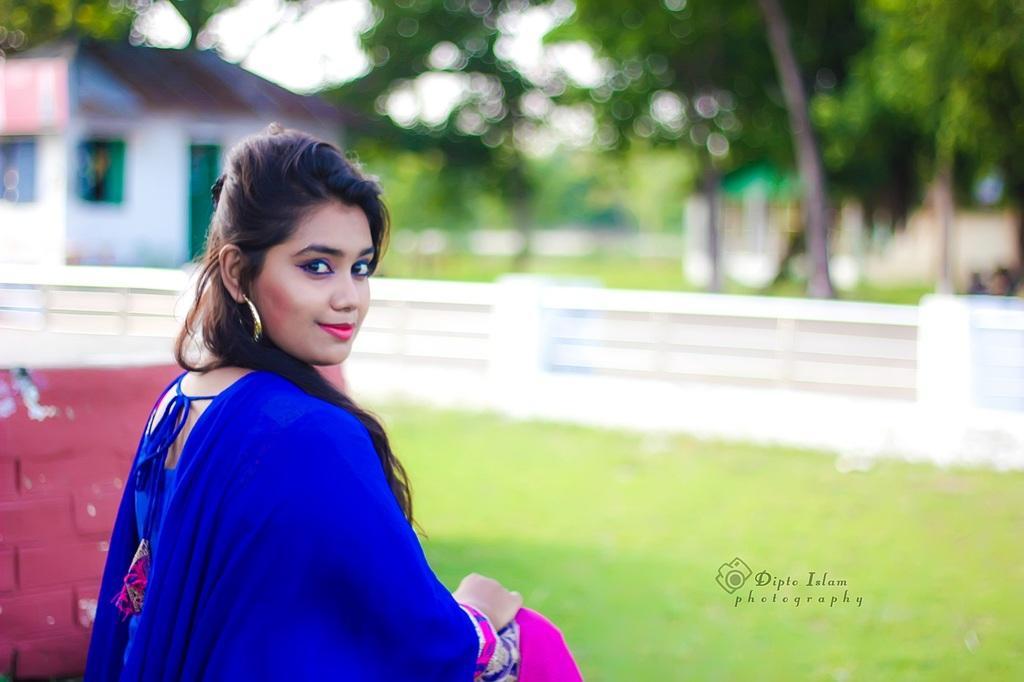Describe this image in one or two sentences. In this image we can see there is a girl sitting on the grass, behind her there is a building and trees. 